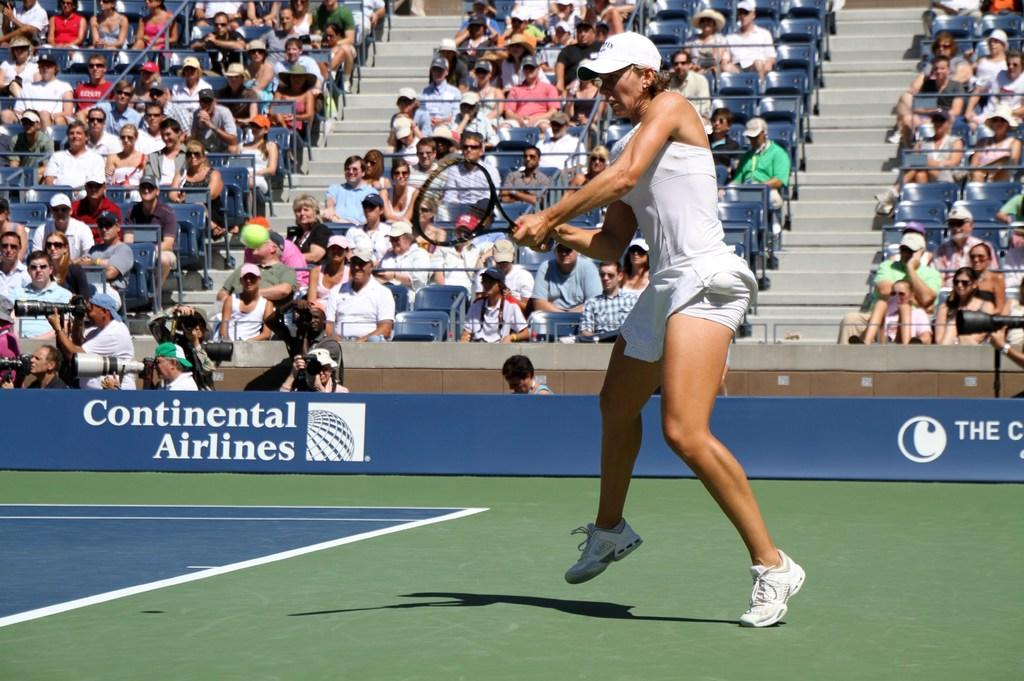What activity is the lady in the image engaged in? The lady in the image is playing tennis. What surface is the tennis game being played on? The tennis court is visible in the image. Are there any other people present in the image besides the lady playing tennis? Yes, there are spectators sitting in chairs in the background of the image. What type of boat is the lady using to play tennis in the image? There is no boat present in the image; the lady is playing tennis on a tennis court. What nation is the lady representing while playing tennis in the image? The image does not provide any information about the lady's nationality or the nation she might be representing. 